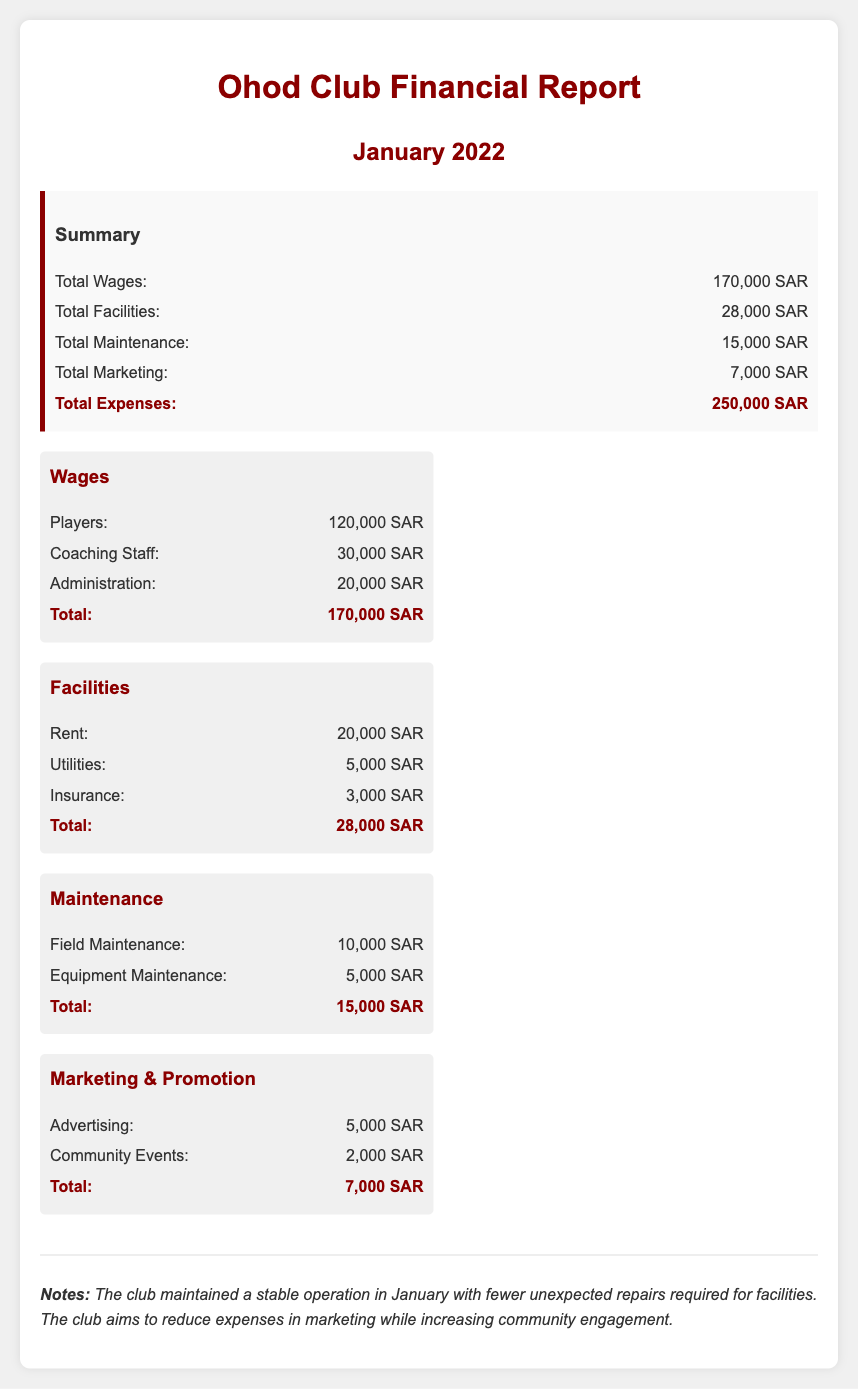What is the total amount spent on wages? The total amount spent on wages is clearly listed in the summary section of the document.
Answer: 170,000 SAR What are the total expenses for January 2022? The total expenses are summarized at the bottom of the report, encompassing all categories.
Answer: 250,000 SAR What was the cost of field maintenance? The field maintenance cost is specified under the maintenance section of the report.
Answer: 10,000 SAR What is the total expenditure on marketing? The total expenditure on marketing is mentioned in the summary and detailed in the marketing section.
Answer: 7,000 SAR How much was spent on rent for facilities? The rent amount for facilities is explicitly mentioned in the facilities section.
Answer: 20,000 SAR What is the total amount allocated for administration wages? The administration wage amount is listed under the wages section of the report.
Answer: 20,000 SAR What category had the highest expense? The highest expense category is determined by comparing the totals in each segment of the report.
Answer: Wages What was the total cost of utilities? The utilities cost is detailed within the facilities breakdown of the financial report.
Answer: 5,000 SAR What note is provided regarding marketing expenses? The notes section provides insight about the marketing strategy and expenses.
Answer: Reduce expenses in marketing while increasing community engagement 